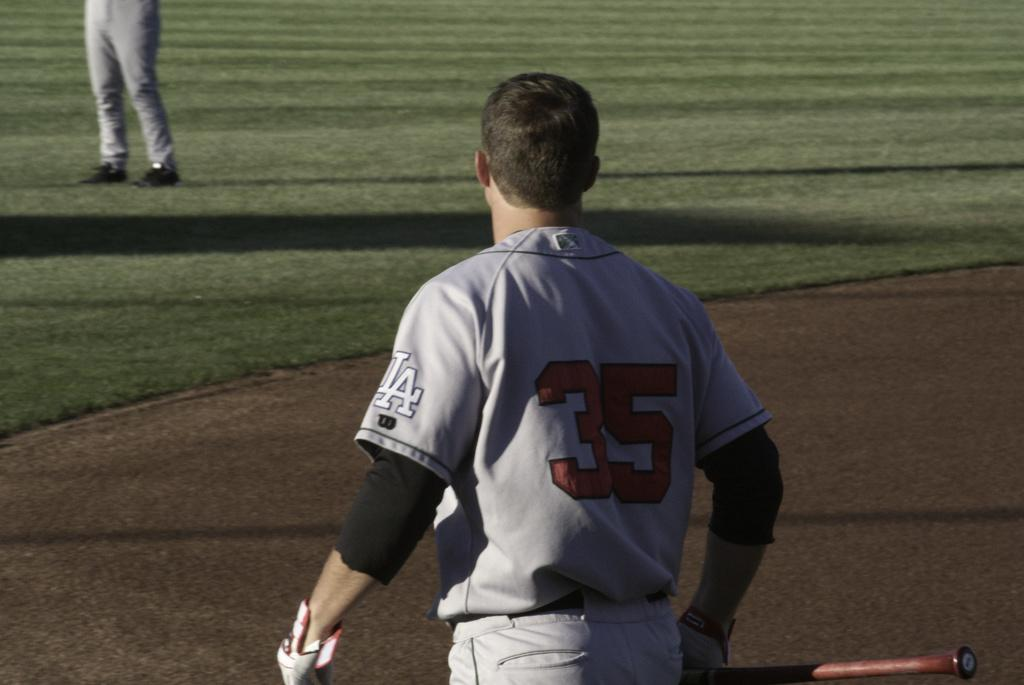<image>
Present a compact description of the photo's key features. Number 35 for L.A. is holding a bat in his right hand. 